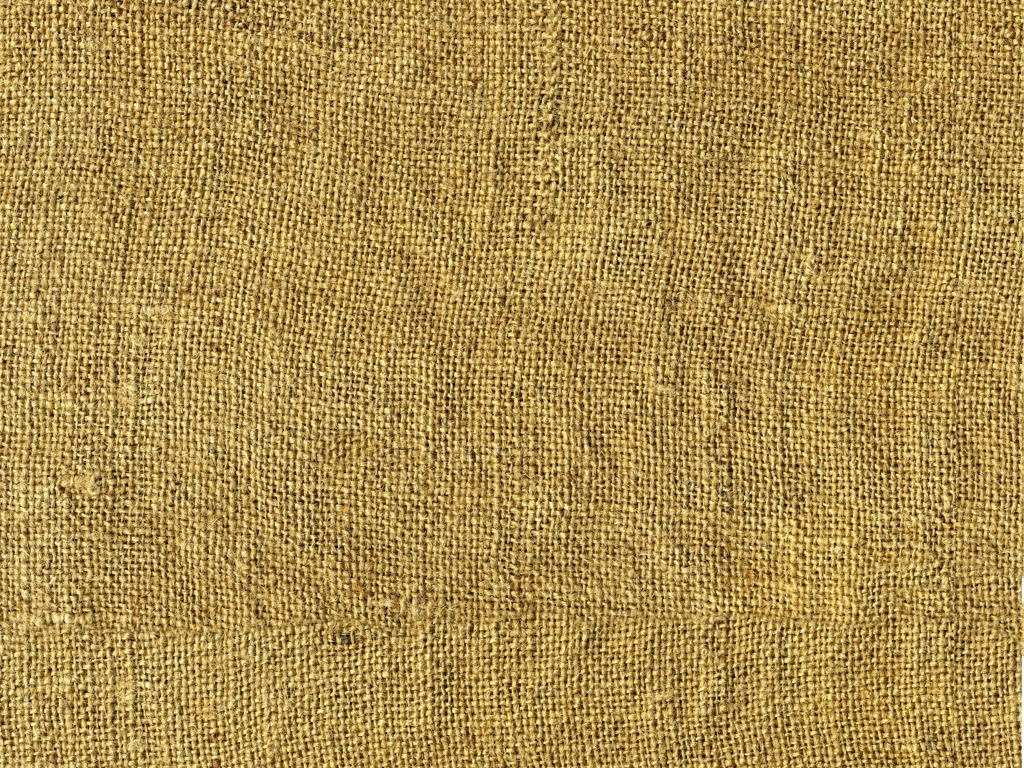Is this texture indicative of a specific quality or grade of the material? The texture suggests a rough, durable quality often associated with high-grade burlap material. The tightly woven, consistent fibers indicate it's sturdy enough for heavy-duty use while the natural imperfections contribute to its authenticity and aesthetic appeal. 